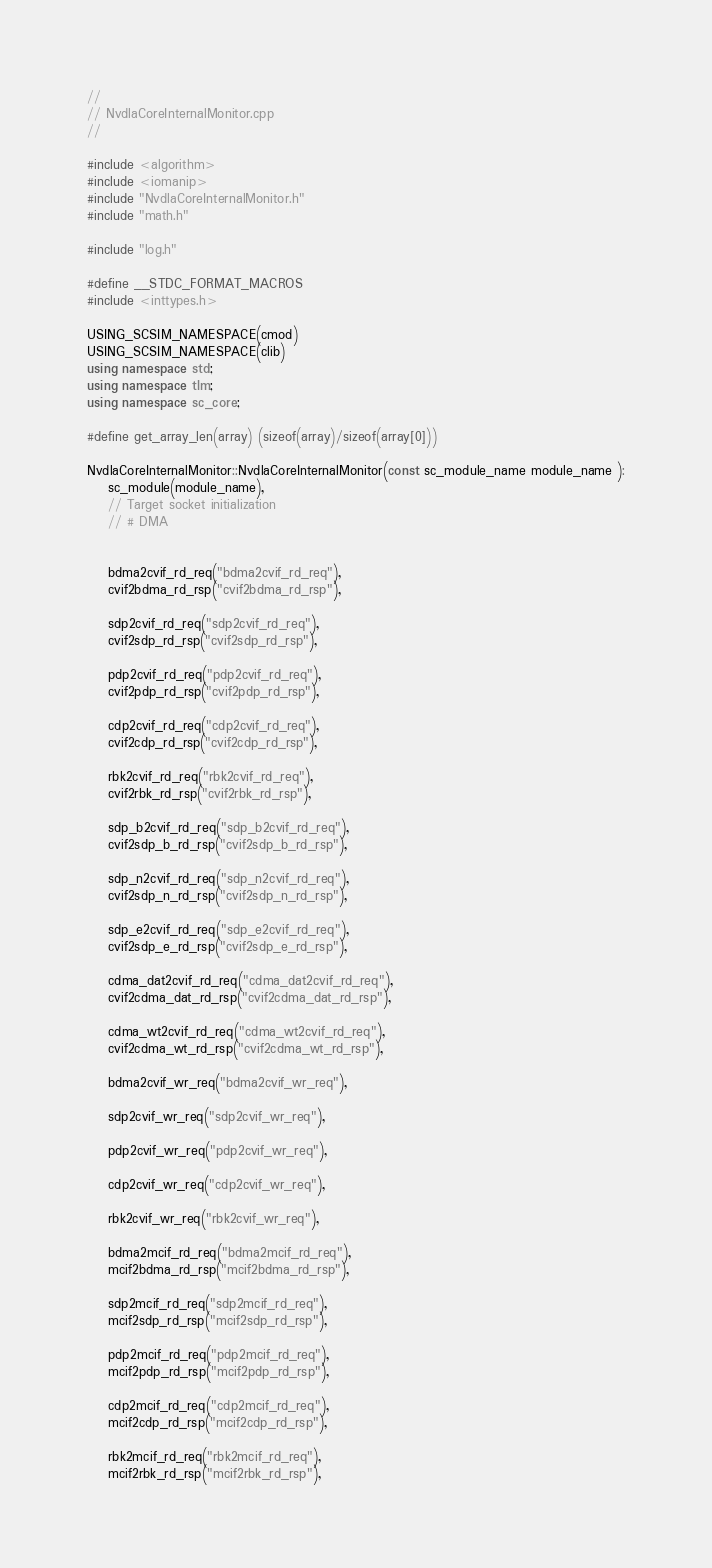Convert code to text. <code><loc_0><loc_0><loc_500><loc_500><_C++_>
//
// NvdlaCoreInternalMonitor.cpp
//

#include <algorithm>
#include <iomanip>
#include "NvdlaCoreInternalMonitor.h"
#include "math.h"

#include "log.h"

#define __STDC_FORMAT_MACROS
#include <inttypes.h>

USING_SCSIM_NAMESPACE(cmod)
USING_SCSIM_NAMESPACE(clib)
using namespace std;
using namespace tlm;
using namespace sc_core;

#define get_array_len(array) (sizeof(array)/sizeof(array[0]))

NvdlaCoreInternalMonitor::NvdlaCoreInternalMonitor(const sc_module_name module_name ):
    sc_module(module_name),
    // Target socket initialization 
    // # DMA


    bdma2cvif_rd_req("bdma2cvif_rd_req"),
    cvif2bdma_rd_rsp("cvif2bdma_rd_rsp"),

    sdp2cvif_rd_req("sdp2cvif_rd_req"),
    cvif2sdp_rd_rsp("cvif2sdp_rd_rsp"),

    pdp2cvif_rd_req("pdp2cvif_rd_req"),
    cvif2pdp_rd_rsp("cvif2pdp_rd_rsp"),

    cdp2cvif_rd_req("cdp2cvif_rd_req"),
    cvif2cdp_rd_rsp("cvif2cdp_rd_rsp"),

    rbk2cvif_rd_req("rbk2cvif_rd_req"),
    cvif2rbk_rd_rsp("cvif2rbk_rd_rsp"),

    sdp_b2cvif_rd_req("sdp_b2cvif_rd_req"),
    cvif2sdp_b_rd_rsp("cvif2sdp_b_rd_rsp"),

    sdp_n2cvif_rd_req("sdp_n2cvif_rd_req"),
    cvif2sdp_n_rd_rsp("cvif2sdp_n_rd_rsp"),

    sdp_e2cvif_rd_req("sdp_e2cvif_rd_req"),
    cvif2sdp_e_rd_rsp("cvif2sdp_e_rd_rsp"),

    cdma_dat2cvif_rd_req("cdma_dat2cvif_rd_req"),
    cvif2cdma_dat_rd_rsp("cvif2cdma_dat_rd_rsp"),

    cdma_wt2cvif_rd_req("cdma_wt2cvif_rd_req"),
    cvif2cdma_wt_rd_rsp("cvif2cdma_wt_rd_rsp"),

    bdma2cvif_wr_req("bdma2cvif_wr_req"),

    sdp2cvif_wr_req("sdp2cvif_wr_req"),

    pdp2cvif_wr_req("pdp2cvif_wr_req"),

    cdp2cvif_wr_req("cdp2cvif_wr_req"),

    rbk2cvif_wr_req("rbk2cvif_wr_req"),

    bdma2mcif_rd_req("bdma2mcif_rd_req"),
    mcif2bdma_rd_rsp("mcif2bdma_rd_rsp"),

    sdp2mcif_rd_req("sdp2mcif_rd_req"),
    mcif2sdp_rd_rsp("mcif2sdp_rd_rsp"),

    pdp2mcif_rd_req("pdp2mcif_rd_req"),
    mcif2pdp_rd_rsp("mcif2pdp_rd_rsp"),

    cdp2mcif_rd_req("cdp2mcif_rd_req"),
    mcif2cdp_rd_rsp("mcif2cdp_rd_rsp"),

    rbk2mcif_rd_req("rbk2mcif_rd_req"),
    mcif2rbk_rd_rsp("mcif2rbk_rd_rsp"),
</code> 